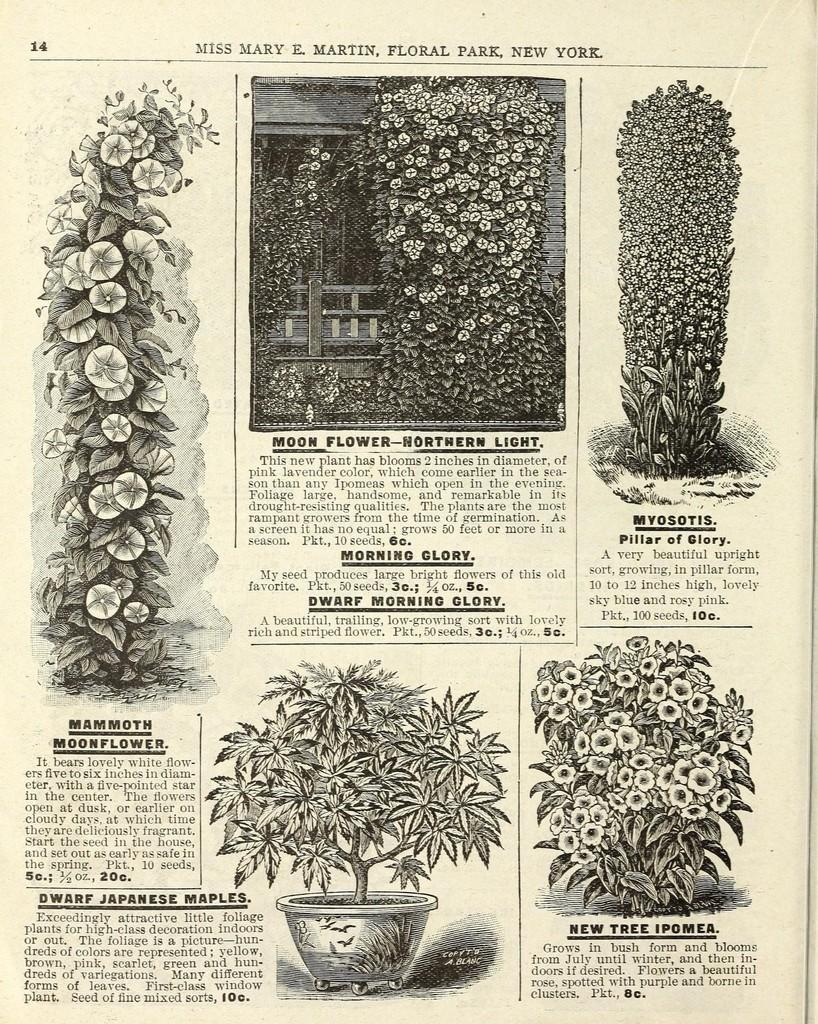What type of image is present in the picture? The image contains a black and white picture. What is the subject of the black and white picture? The picture depicts a group of plants and flowers. Is there any text associated with the black and white picture? Yes, the picture is on some text. What can be seen at the bottom of the image? There is a plant in a pot at the bottom of the image. On what surface is the pot placed? The pot is placed on a surface. What type of jelly is being used to cover the flowers in the image? There is no jelly present in the image, and the flowers are not being covered by any substance. 